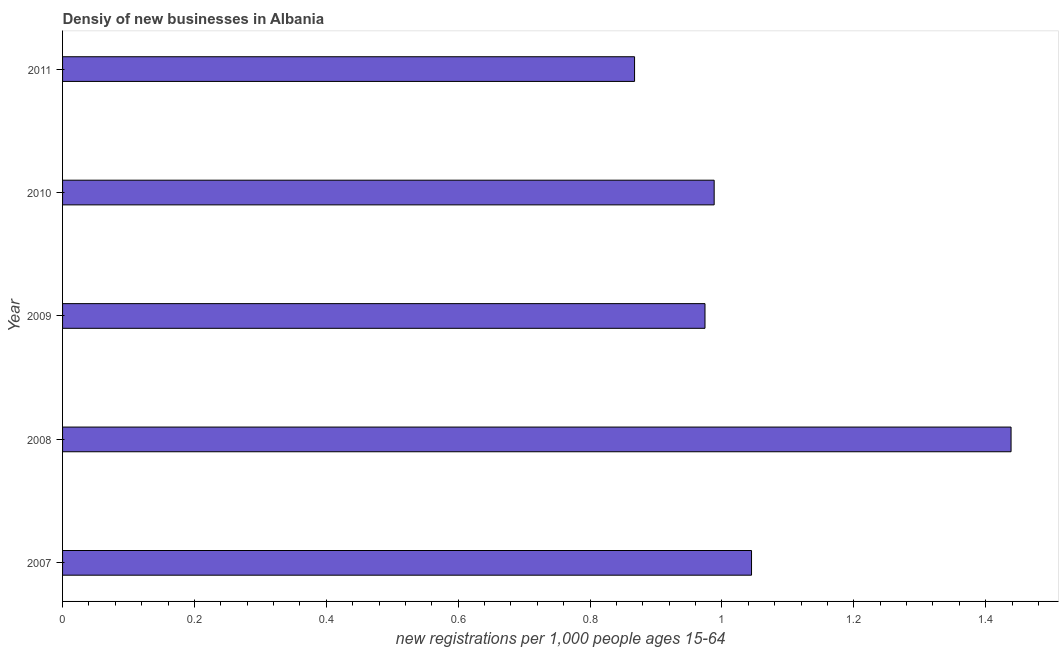What is the title of the graph?
Make the answer very short. Densiy of new businesses in Albania. What is the label or title of the X-axis?
Your response must be concise. New registrations per 1,0 people ages 15-64. What is the label or title of the Y-axis?
Make the answer very short. Year. What is the density of new business in 2007?
Offer a terse response. 1.04. Across all years, what is the maximum density of new business?
Offer a terse response. 1.44. Across all years, what is the minimum density of new business?
Give a very brief answer. 0.87. In which year was the density of new business maximum?
Your answer should be compact. 2008. In which year was the density of new business minimum?
Offer a terse response. 2011. What is the sum of the density of new business?
Your response must be concise. 5.31. What is the difference between the density of new business in 2007 and 2009?
Offer a terse response. 0.07. What is the average density of new business per year?
Give a very brief answer. 1.06. What is the median density of new business?
Offer a terse response. 0.99. In how many years, is the density of new business greater than 0.24 ?
Give a very brief answer. 5. What is the ratio of the density of new business in 2008 to that in 2009?
Your response must be concise. 1.48. What is the difference between the highest and the second highest density of new business?
Your answer should be compact. 0.39. Is the sum of the density of new business in 2009 and 2010 greater than the maximum density of new business across all years?
Offer a very short reply. Yes. What is the difference between the highest and the lowest density of new business?
Provide a succinct answer. 0.57. What is the difference between two consecutive major ticks on the X-axis?
Give a very brief answer. 0.2. What is the new registrations per 1,000 people ages 15-64 in 2007?
Make the answer very short. 1.04. What is the new registrations per 1,000 people ages 15-64 of 2008?
Offer a terse response. 1.44. What is the new registrations per 1,000 people ages 15-64 in 2009?
Keep it short and to the point. 0.97. What is the new registrations per 1,000 people ages 15-64 of 2010?
Keep it short and to the point. 0.99. What is the new registrations per 1,000 people ages 15-64 of 2011?
Make the answer very short. 0.87. What is the difference between the new registrations per 1,000 people ages 15-64 in 2007 and 2008?
Ensure brevity in your answer.  -0.39. What is the difference between the new registrations per 1,000 people ages 15-64 in 2007 and 2009?
Provide a succinct answer. 0.07. What is the difference between the new registrations per 1,000 people ages 15-64 in 2007 and 2010?
Ensure brevity in your answer.  0.06. What is the difference between the new registrations per 1,000 people ages 15-64 in 2007 and 2011?
Make the answer very short. 0.18. What is the difference between the new registrations per 1,000 people ages 15-64 in 2008 and 2009?
Keep it short and to the point. 0.46. What is the difference between the new registrations per 1,000 people ages 15-64 in 2008 and 2010?
Your answer should be very brief. 0.45. What is the difference between the new registrations per 1,000 people ages 15-64 in 2008 and 2011?
Offer a terse response. 0.57. What is the difference between the new registrations per 1,000 people ages 15-64 in 2009 and 2010?
Give a very brief answer. -0.01. What is the difference between the new registrations per 1,000 people ages 15-64 in 2009 and 2011?
Make the answer very short. 0.11. What is the difference between the new registrations per 1,000 people ages 15-64 in 2010 and 2011?
Your response must be concise. 0.12. What is the ratio of the new registrations per 1,000 people ages 15-64 in 2007 to that in 2008?
Offer a very short reply. 0.73. What is the ratio of the new registrations per 1,000 people ages 15-64 in 2007 to that in 2009?
Provide a short and direct response. 1.07. What is the ratio of the new registrations per 1,000 people ages 15-64 in 2007 to that in 2010?
Give a very brief answer. 1.06. What is the ratio of the new registrations per 1,000 people ages 15-64 in 2007 to that in 2011?
Provide a short and direct response. 1.2. What is the ratio of the new registrations per 1,000 people ages 15-64 in 2008 to that in 2009?
Make the answer very short. 1.48. What is the ratio of the new registrations per 1,000 people ages 15-64 in 2008 to that in 2010?
Your response must be concise. 1.46. What is the ratio of the new registrations per 1,000 people ages 15-64 in 2008 to that in 2011?
Offer a very short reply. 1.66. What is the ratio of the new registrations per 1,000 people ages 15-64 in 2009 to that in 2011?
Your answer should be very brief. 1.12. What is the ratio of the new registrations per 1,000 people ages 15-64 in 2010 to that in 2011?
Keep it short and to the point. 1.14. 